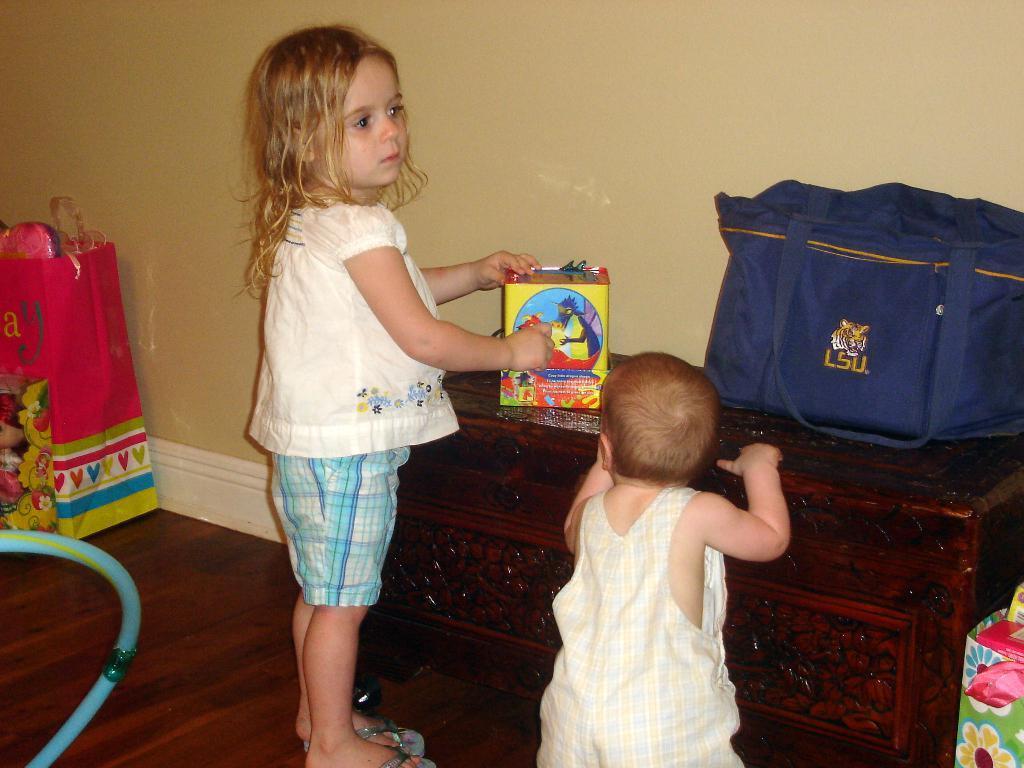How would you summarize this image in a sentence or two? In this image I can see two people standing and one person is holding a box. I can see a blue bag on the table. I can see a cream wall and few objects on the floor. 